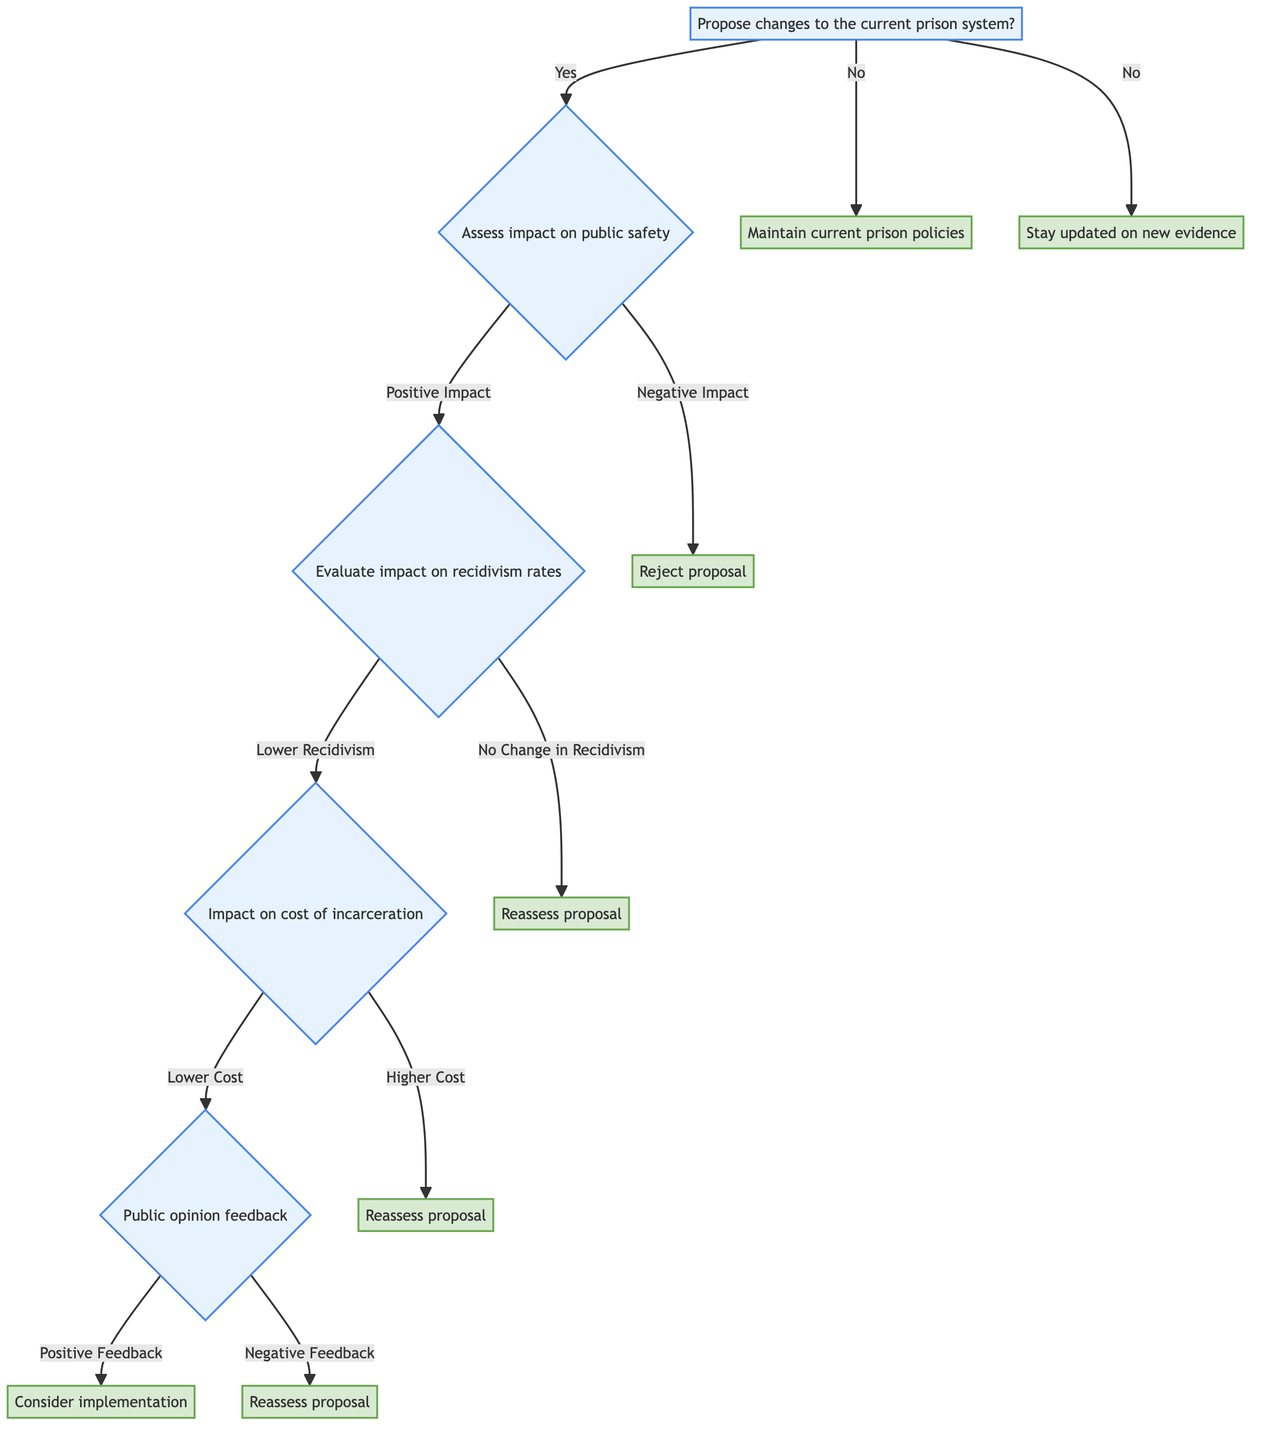What is the root question of the diagram? The diagram begins with the root question "Propose changes to the current prison system?"
Answer: Propose changes to the current prison system? What happens if the impact on public safety is assessed as negative? If the impact is negative, the diagram states that the proposal is rejected, marking the endpoint of that branch.
Answer: Reject proposal How many outcomes are there from the "no" branch? The "no" branch leads to two outcomes: "Maintain current prison policies" and "Stay updated on new evidence," totaling two distinct outcomes.
Answer: 2 If recidivism rates show no change, what is the next step? The evaluation of recidivism rates leading to "no change" prompts a reassessment of the proposal, as per the flow of the diagram.
Answer: Reassess proposal What does the diagram indicate will happen if public opinion feedback is negative? If public opinion feedback is negative, the next action is to reassess the proposal, as stated in the diagram.
Answer: Reassess proposal What must occur for a proposal to be considered for implementation? The proposal can only be considered for implementation if public opinion feedback is positive, according to the logic laid out in the diagram.
Answer: Consider implementation What does the "lowerCost" branch lead to? Following the "lowerCost" branch from the impact on cost of incarceration, the next step leads to public opinion feedback, as shown in the diagram.
Answer: Public opinion feedback If recidivism rates are lower, what is the next question assessed in the diagram? The subsequent question after confirming lower recidivism rates is assessing the impact on the cost of incarceration.
Answer: Impact on cost of incarceration What does the diagram conclude if the current prison system is maintained? The conclusion when maintaining the current prison system is to support current policies without making changes.
Answer: Maintain current prison policies 